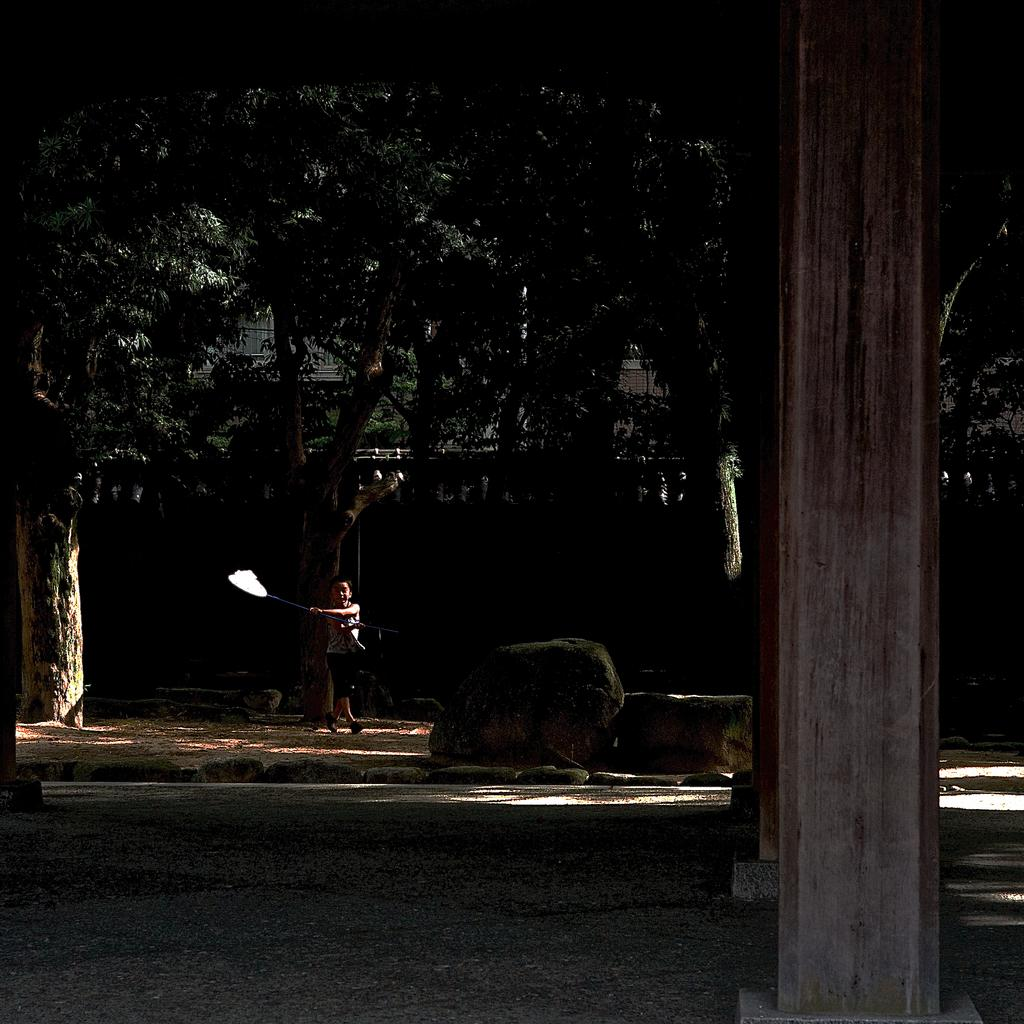What are the children holding in the image? The children are holding an object in the image. What type of natural elements can be seen in the image? There are stones and trees present in the image. What architectural features are visible in the image? There are pillars visible in the image. What is the lighting condition in the image? The image is dark. How many chairs are visible in the image? There are no chairs present in the image. What is the acoustics like in the image? The provided facts do not give any information about the acoustics in the image. 